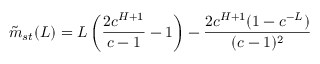<formula> <loc_0><loc_0><loc_500><loc_500>\tilde { m } _ { s t } ( L ) = L \left ( \frac { 2 c ^ { H + 1 } } { c - 1 } - 1 \right ) - \frac { 2 c ^ { H + 1 } ( 1 - c ^ { - L } ) } { ( c - 1 ) ^ { 2 } }</formula> 